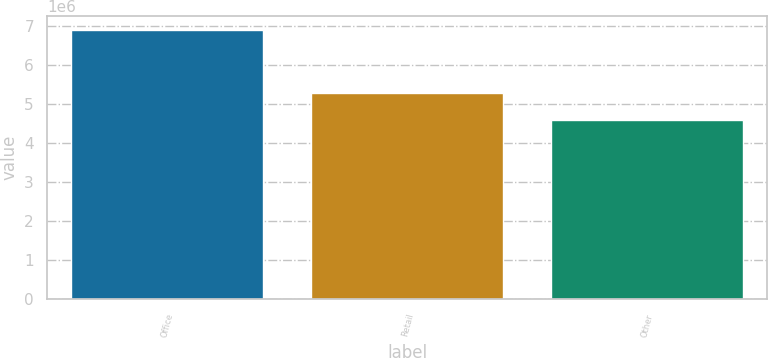Convert chart to OTSL. <chart><loc_0><loc_0><loc_500><loc_500><bar_chart><fcel>Office<fcel>Retail<fcel>Other<nl><fcel>6.909e+06<fcel>5.274e+06<fcel>4.592e+06<nl></chart> 